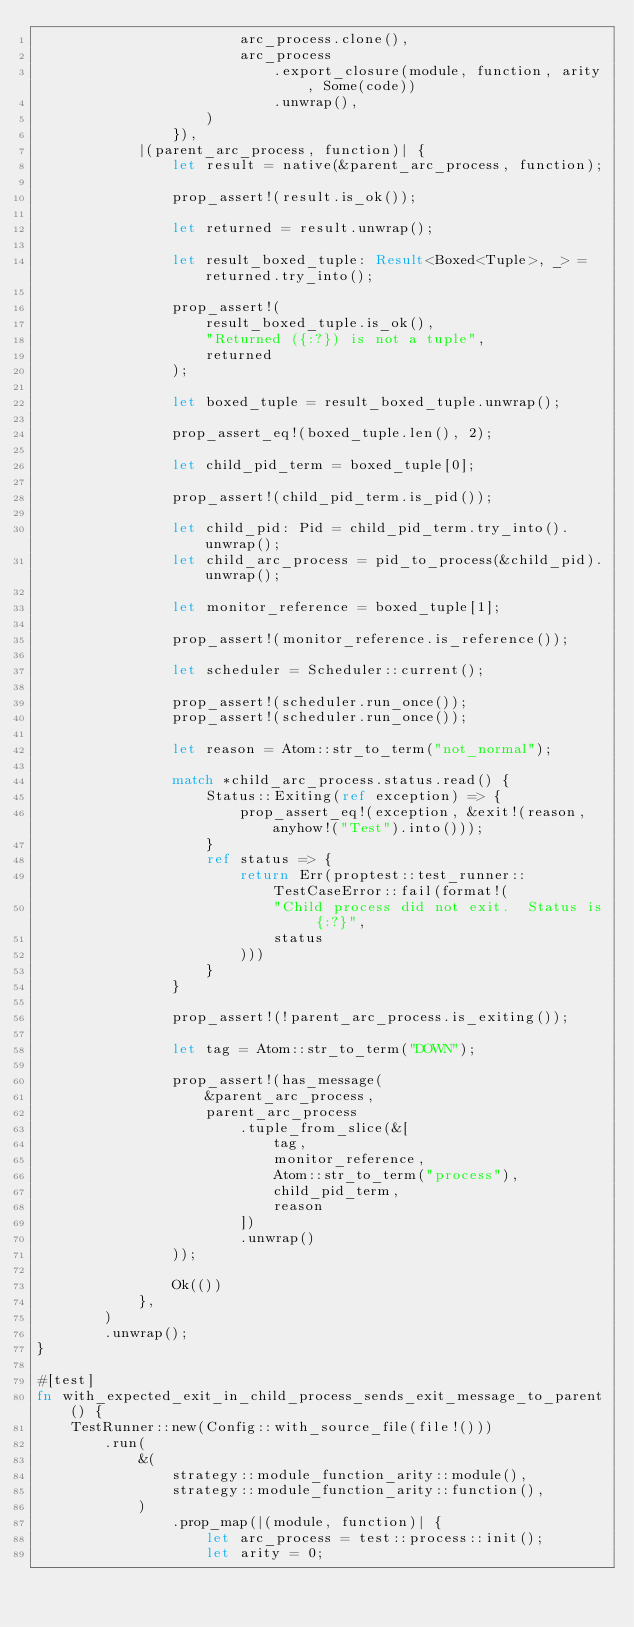<code> <loc_0><loc_0><loc_500><loc_500><_Rust_>                        arc_process.clone(),
                        arc_process
                            .export_closure(module, function, arity, Some(code))
                            .unwrap(),
                    )
                }),
            |(parent_arc_process, function)| {
                let result = native(&parent_arc_process, function);

                prop_assert!(result.is_ok());

                let returned = result.unwrap();

                let result_boxed_tuple: Result<Boxed<Tuple>, _> = returned.try_into();

                prop_assert!(
                    result_boxed_tuple.is_ok(),
                    "Returned ({:?}) is not a tuple",
                    returned
                );

                let boxed_tuple = result_boxed_tuple.unwrap();

                prop_assert_eq!(boxed_tuple.len(), 2);

                let child_pid_term = boxed_tuple[0];

                prop_assert!(child_pid_term.is_pid());

                let child_pid: Pid = child_pid_term.try_into().unwrap();
                let child_arc_process = pid_to_process(&child_pid).unwrap();

                let monitor_reference = boxed_tuple[1];

                prop_assert!(monitor_reference.is_reference());

                let scheduler = Scheduler::current();

                prop_assert!(scheduler.run_once());
                prop_assert!(scheduler.run_once());

                let reason = Atom::str_to_term("not_normal");

                match *child_arc_process.status.read() {
                    Status::Exiting(ref exception) => {
                        prop_assert_eq!(exception, &exit!(reason, anyhow!("Test").into()));
                    }
                    ref status => {
                        return Err(proptest::test_runner::TestCaseError::fail(format!(
                            "Child process did not exit.  Status is {:?}",
                            status
                        )))
                    }
                }

                prop_assert!(!parent_arc_process.is_exiting());

                let tag = Atom::str_to_term("DOWN");

                prop_assert!(has_message(
                    &parent_arc_process,
                    parent_arc_process
                        .tuple_from_slice(&[
                            tag,
                            monitor_reference,
                            Atom::str_to_term("process"),
                            child_pid_term,
                            reason
                        ])
                        .unwrap()
                ));

                Ok(())
            },
        )
        .unwrap();
}

#[test]
fn with_expected_exit_in_child_process_sends_exit_message_to_parent() {
    TestRunner::new(Config::with_source_file(file!()))
        .run(
            &(
                strategy::module_function_arity::module(),
                strategy::module_function_arity::function(),
            )
                .prop_map(|(module, function)| {
                    let arc_process = test::process::init();
                    let arity = 0;</code> 